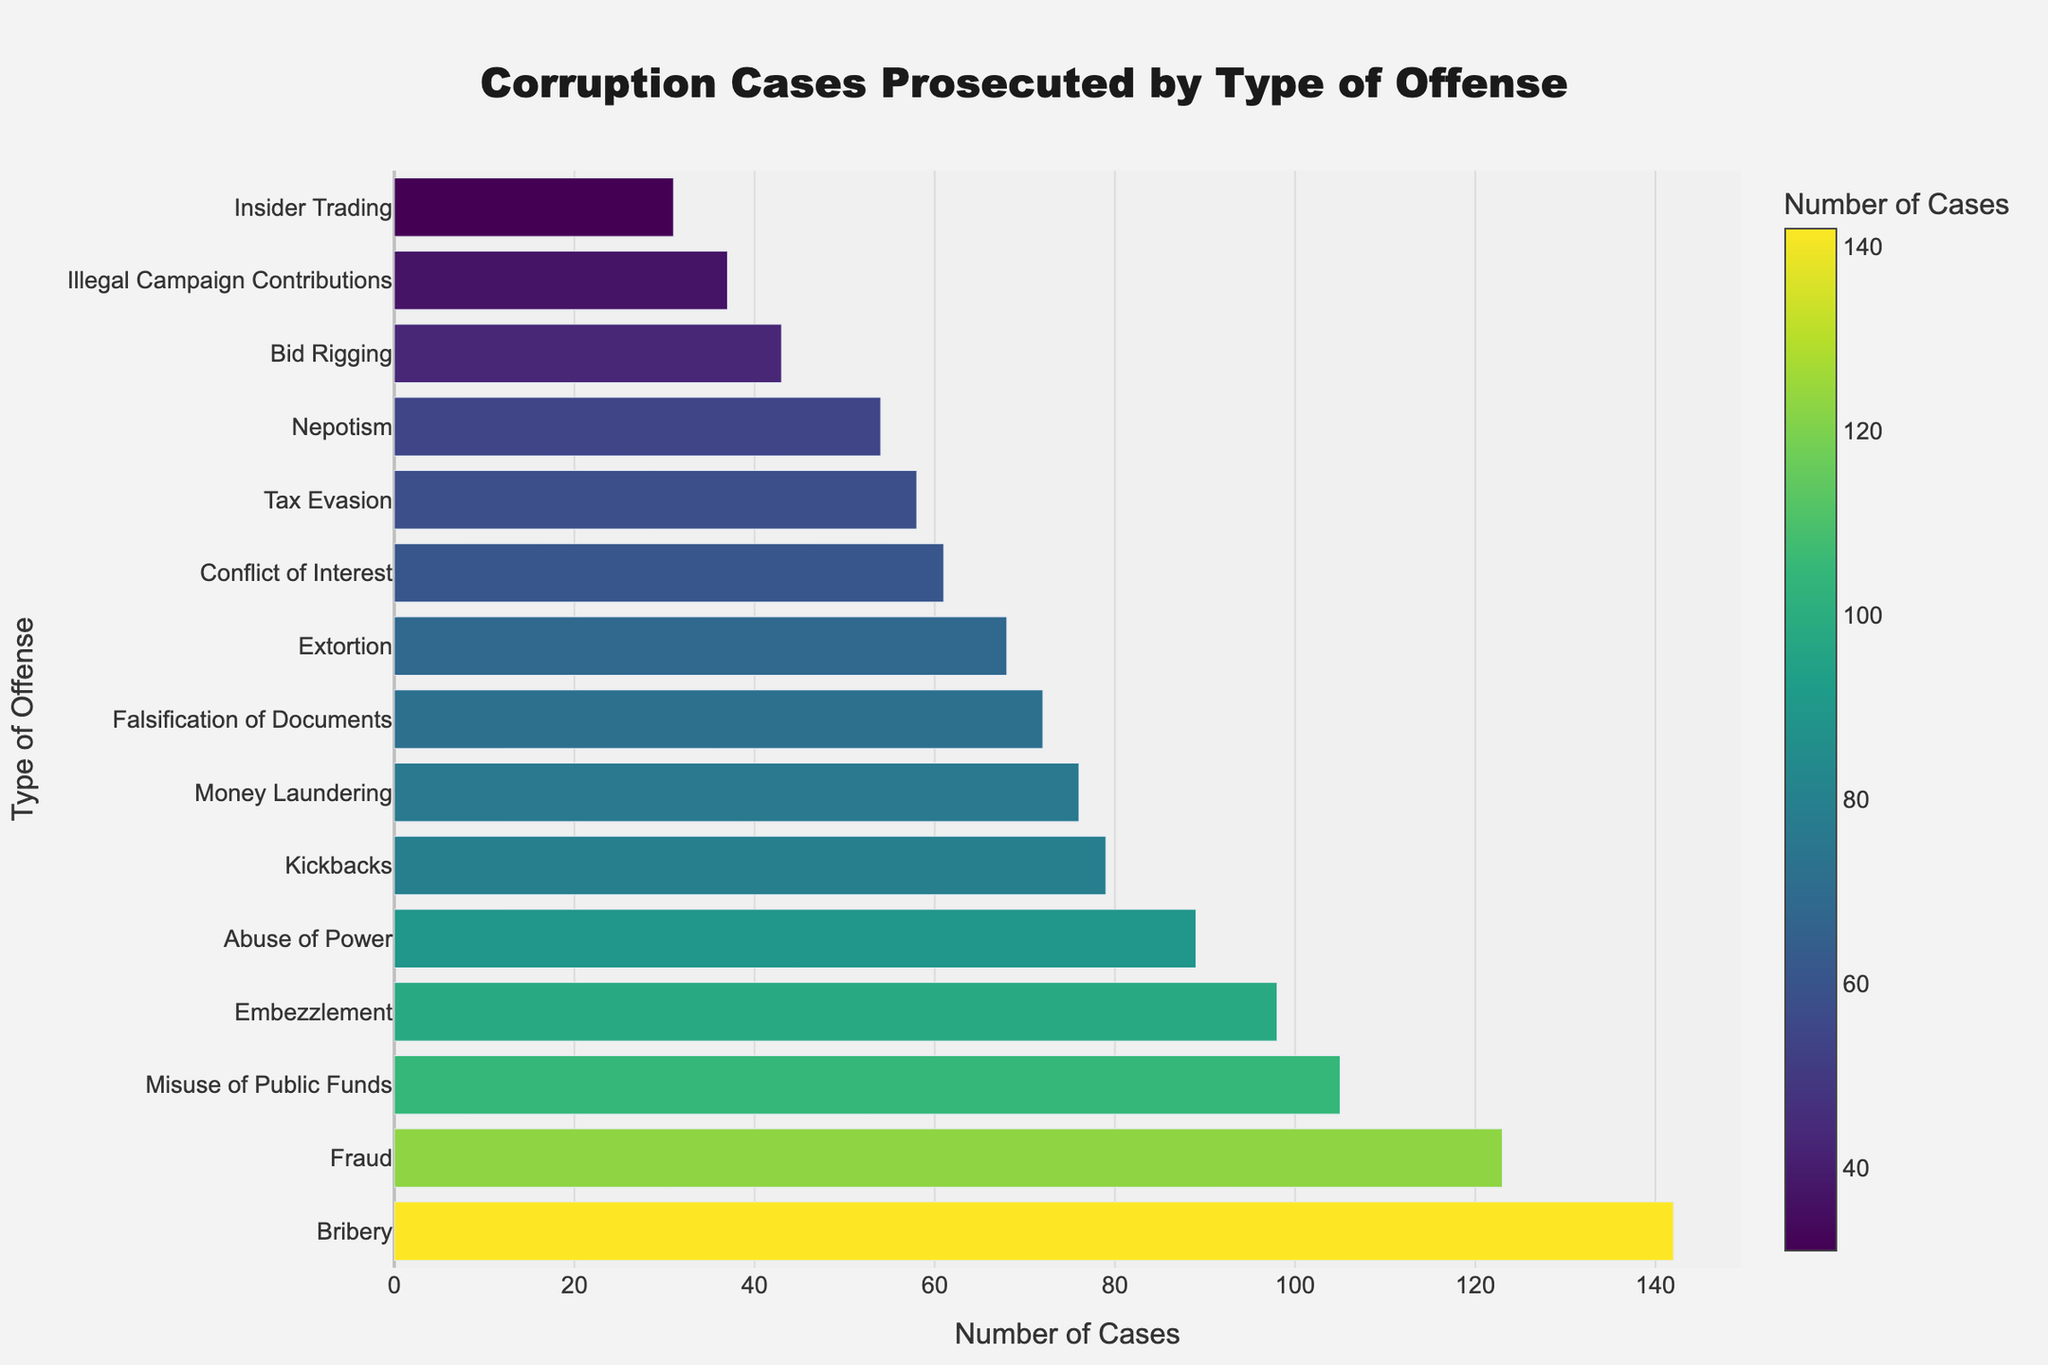Which type of offense has the highest number of cases? The figure shows different types of offenses on the y-axis and the number of cases on the x-axis. The longest bar represents the type of offense with the highest number of cases. The bar for "Bribery" is the longest.
Answer: Bribery Which type of offense has the second-highest number of cases? After identifying the longest bar for "Bribery," look for the second-longest bar. The bar for "Fraud" is the second-longest.
Answer: Fraud Which offenses have fewer than 50 cases? Identify bars that do not reach the 50 mark on the x-axis. The offenses are "Nepotism," "Illegal Campaign Contributions," "Bid Rigging," and "Insider Trading."
Answer: Nepotism, Illegal Campaign Contributions, Bid Rigging, Insider Trading How many more cases of Bribery are there compared to Embezzlement? Note the number of cases for Bribery (142) and Embezzlement (98). Subtract the number of Embezzlement cases from Bribery cases: 142 - 98.
Answer: 44 What's the total number of cases for the top 3 offenses? Identify the top 3 offenses by number of cases: Bribery (142), Fraud (123), and Misuse of Public Funds (105). Sum these numbers: 142 + 123 + 105.
Answer: 370 Which offense has a similar number of cases to Nepotism? Identify the bar for Nepotism (54 cases) and look for other bars of a similar length. The closest in number is "Extortion" with 68 cases.
Answer: Extortion How much longer is the bar for Tax Evasion compared to Insider Trading? Observe the bars for Tax Evasion (58 cases) and Insider Trading (31 cases). Subtract the number of cases of Insider Trading from Tax Evasion: 58 - 31.
Answer: 27 Which offenses have approximately the same number of cases? Identify bars of similar lengths. "Money Laundering" (76) and "Kickbacks" (79) have very close case numbers.
Answer: Money Laundering, Kickbacks What is the average number of cases for Abuse of Power, Illegal Campaign Contributions, and Falsification of Documents? Identify the number of cases for each: Abuse of Power (89), Illegal Campaign Contributions (37), Falsification of Documents (72). Calculate their average: (89 + 37 + 72) / 3.
Answer: 66 Which type of offense has a color that is very different from most of the other colors on the chart? Look for an outlier in the color scale used, representing significantly higher or lower values compared to others. "Insider Trading" has noticeably fewer cases and thus, a markedly different color compared to most others.
Answer: Insider Trading 